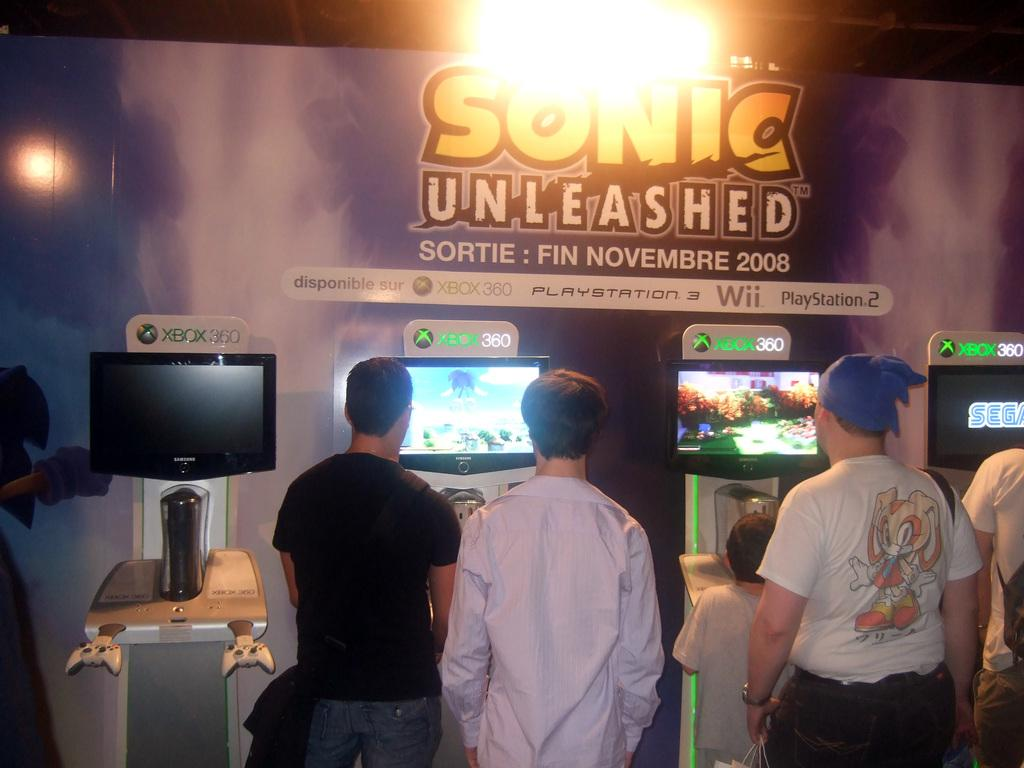What is the main subject of the image? There is a boy in the image. How many people are standing at the screen? There are four persons standing at the screen. Can you describe the screen and its position? The screen is on a stand. What can be seen in the background of the image? There is a hoarding, a light, and poles in the background of the image. What type of plough is being used by the boy in the image? There is no plough present in the image; it features a boy and a screen with four people standing at it. Can you describe the artistic style of the hoarding in the background? The provided facts do not mention any specific artistic style for the hoarding in the background. --- Facts: 1. There is a car in the image. 2. The car is parked on the street. 3. There are trees on both sides of the street. 4. The sky is visible in the image. 5. There is a traffic light in the background of the image. Absurd Topics: parrot, sand, mountain Conversation: What is the main subject of the image? There is a car in the image. Where is the car located? The car is parked on the street. What can be seen on both sides of the street? There are trees on both sides of the street. What is visible in the background of the image? The sky and a traffic light are visible in the background of the image. Reasoning: Let's think step by step in order to produce the conversation. We start by identifying the main subject of the image, which is the car. Then, we describe the car's location, noting that it is parked on the street. Next, we mention the trees on both sides of the street and the sky visible in the background. Finally, we acknowledge the presence of a traffic light in the background. Absurd Question/Answer: Can you tell me how many parrots are sitting on the car in the image? There are no parrots present in the image; it features a car parked on the street with trees on both sides and a traffic light in the background. What type of mountain can be seen in the distance in the image? There is no mountain visible in the image; it only shows a car, trees, the sky, and a traffic light. 